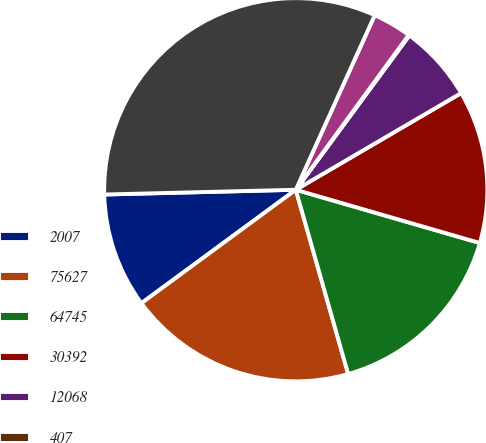<chart> <loc_0><loc_0><loc_500><loc_500><pie_chart><fcel>2007<fcel>75627<fcel>64745<fcel>30392<fcel>12068<fcel>407<fcel>(579)<fcel>167469<nl><fcel>9.69%<fcel>19.32%<fcel>16.11%<fcel>12.9%<fcel>6.48%<fcel>0.07%<fcel>3.27%<fcel>32.15%<nl></chart> 